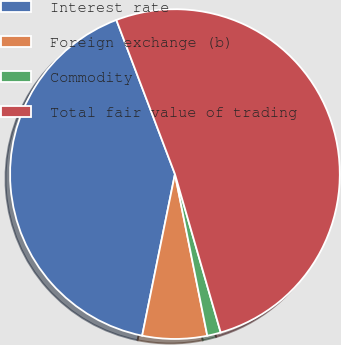<chart> <loc_0><loc_0><loc_500><loc_500><pie_chart><fcel>Interest rate<fcel>Foreign exchange (b)<fcel>Commodity<fcel>Total fair value of trading<nl><fcel>41.03%<fcel>6.33%<fcel>1.33%<fcel>51.3%<nl></chart> 